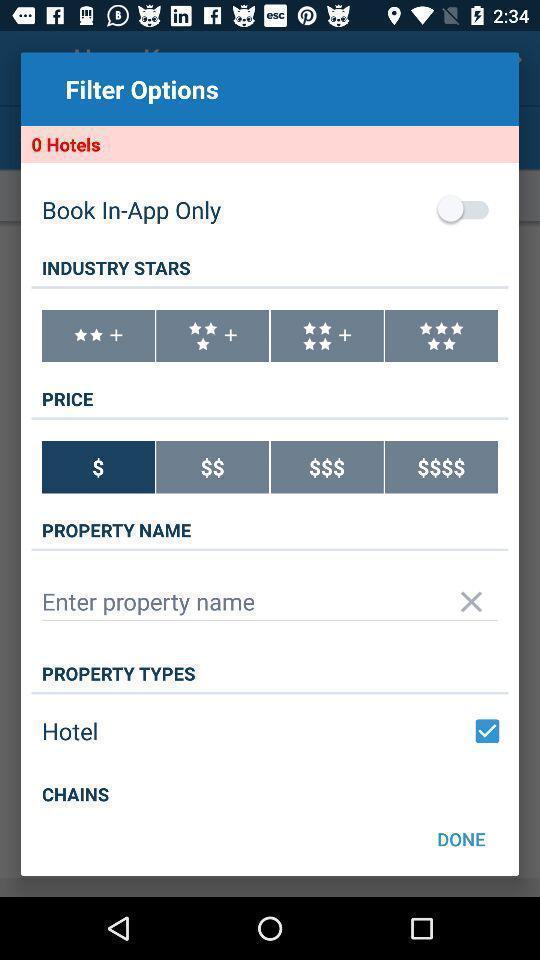What can you discern from this picture? Pop-up showing filter options for hotel booking. 